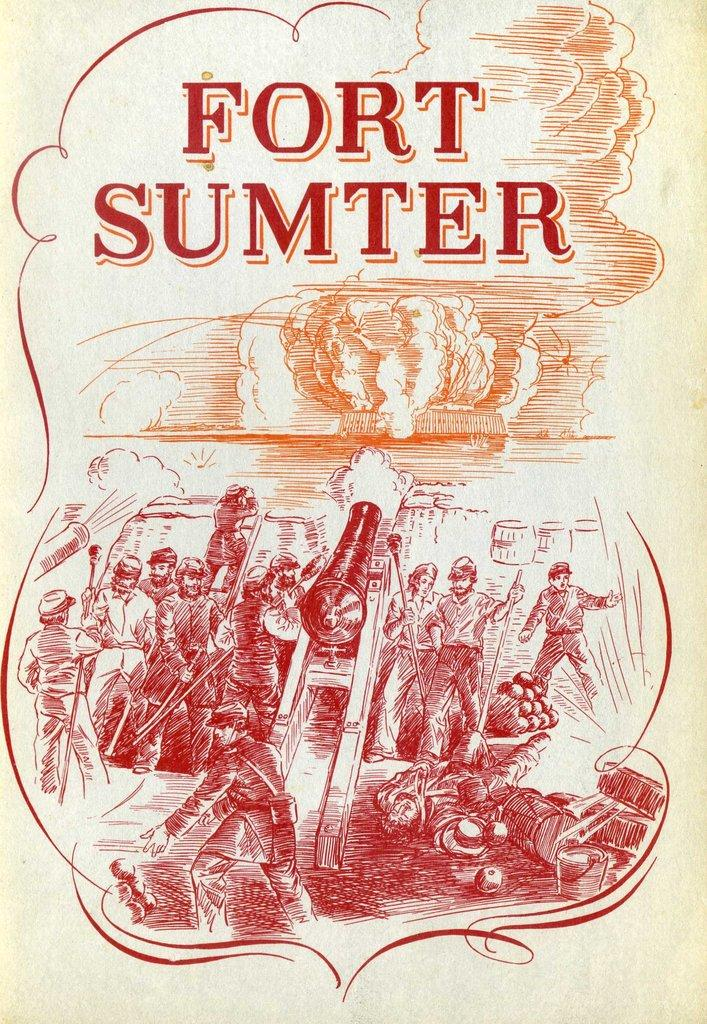<image>
Share a concise interpretation of the image provided. Label showing people firing a canon and the words "Fort Sumter" on top. 